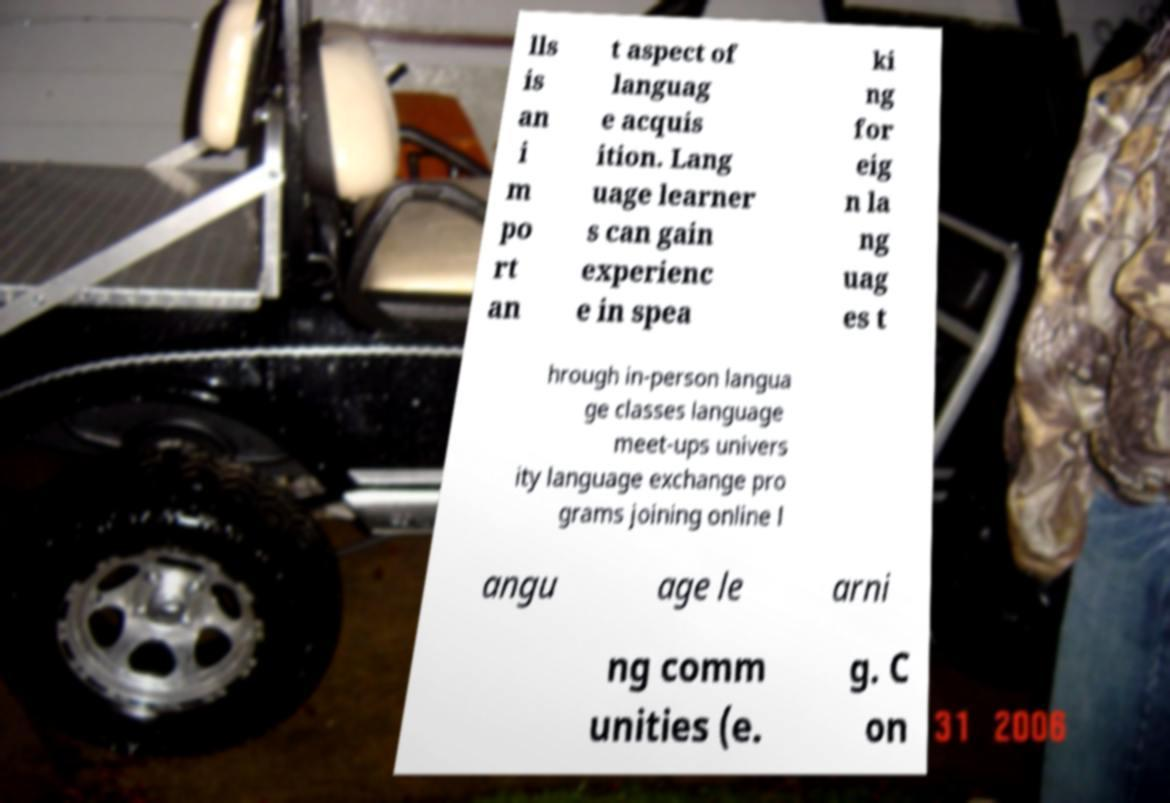Please identify and transcribe the text found in this image. lls is an i m po rt an t aspect of languag e acquis ition. Lang uage learner s can gain experienc e in spea ki ng for eig n la ng uag es t hrough in-person langua ge classes language meet-ups univers ity language exchange pro grams joining online l angu age le arni ng comm unities (e. g. C on 